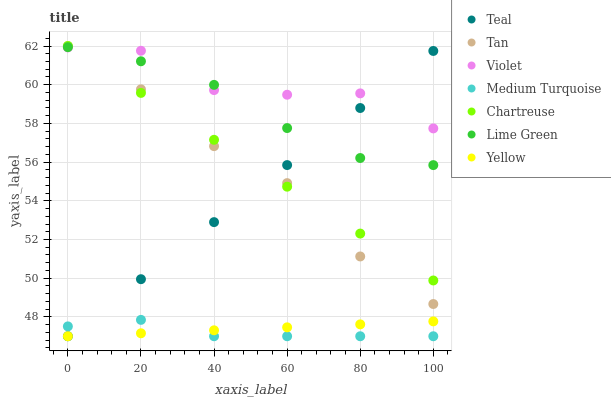Does Medium Turquoise have the minimum area under the curve?
Answer yes or no. Yes. Does Violet have the maximum area under the curve?
Answer yes or no. Yes. Does Yellow have the minimum area under the curve?
Answer yes or no. No. Does Yellow have the maximum area under the curve?
Answer yes or no. No. Is Teal the smoothest?
Answer yes or no. Yes. Is Violet the roughest?
Answer yes or no. Yes. Is Chartreuse the smoothest?
Answer yes or no. No. Is Chartreuse the roughest?
Answer yes or no. No. Does Teal have the lowest value?
Answer yes or no. Yes. Does Chartreuse have the lowest value?
Answer yes or no. No. Does Tan have the highest value?
Answer yes or no. Yes. Does Yellow have the highest value?
Answer yes or no. No. Is Yellow less than Lime Green?
Answer yes or no. Yes. Is Violet greater than Yellow?
Answer yes or no. Yes. Does Teal intersect Tan?
Answer yes or no. Yes. Is Teal less than Tan?
Answer yes or no. No. Is Teal greater than Tan?
Answer yes or no. No. Does Yellow intersect Lime Green?
Answer yes or no. No. 